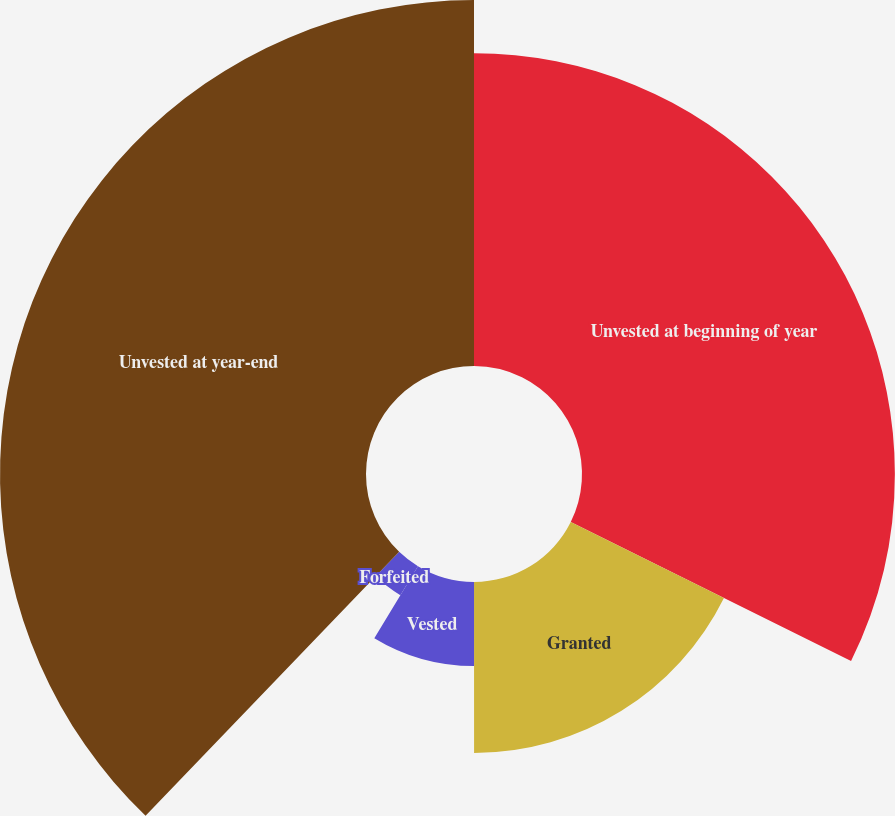Convert chart. <chart><loc_0><loc_0><loc_500><loc_500><pie_chart><fcel>Unvested at beginning of year<fcel>Granted<fcel>Vested<fcel>Forfeited<fcel>Unvested at year-end<nl><fcel>32.33%<fcel>17.67%<fcel>8.69%<fcel>3.5%<fcel>37.82%<nl></chart> 